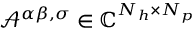<formula> <loc_0><loc_0><loc_500><loc_500>\mathcal { A } ^ { \alpha \beta , \sigma } \in \mathbb { C } ^ { N _ { h } \times N _ { p } }</formula> 